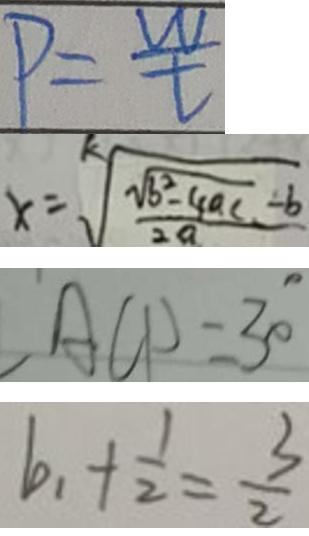Convert formula to latex. <formula><loc_0><loc_0><loc_500><loc_500>P = \frac { w } { t } 
 x = \sqrt [ k ] { \frac { \sqrt { b ^ { 2 } - 4 a c } - b } { 2 a } } 
 A C D = 3 0 ^ { \circ } 
 b _ { 1 } + \frac { 1 } { 2 } = \frac { 3 } { 2 }</formula> 